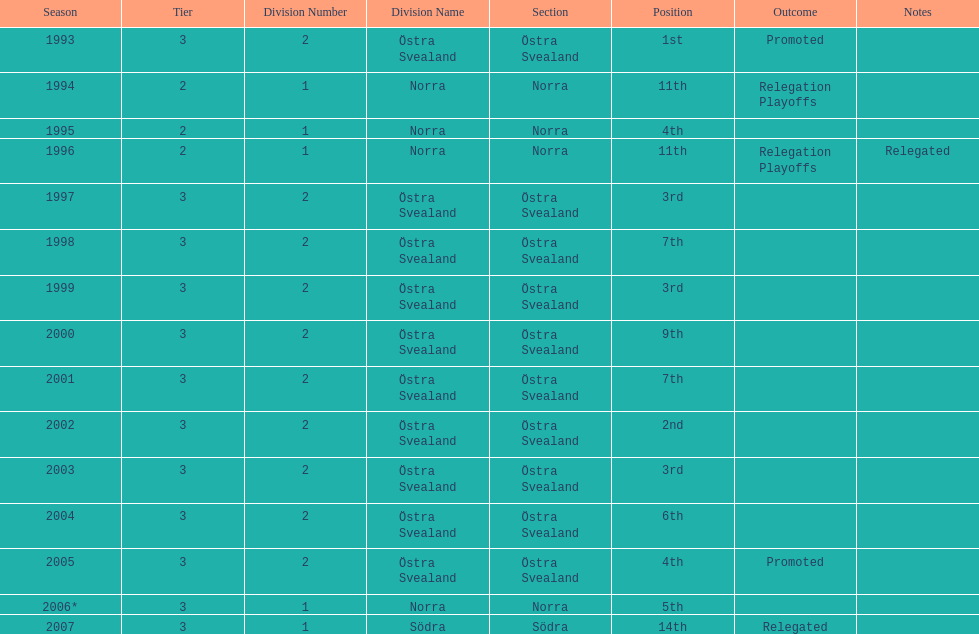In what season did visby if gute fk finish first in division 2 tier 3? 1993. 